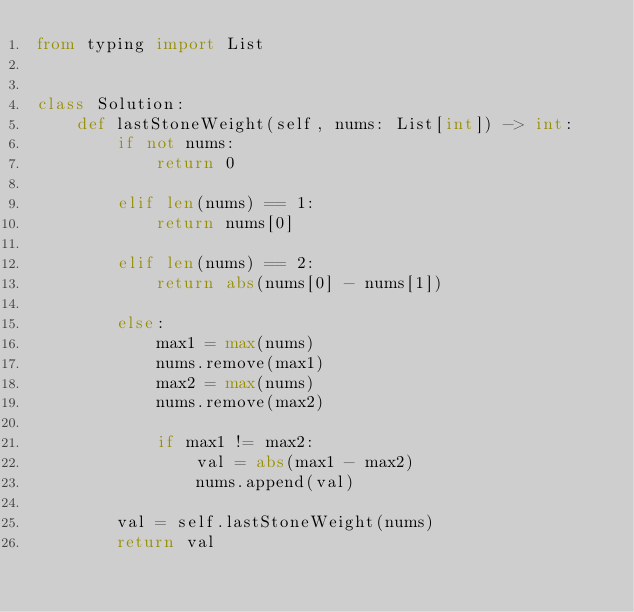Convert code to text. <code><loc_0><loc_0><loc_500><loc_500><_Python_>from typing import List


class Solution:
    def lastStoneWeight(self, nums: List[int]) -> int:
        if not nums:
            return 0

        elif len(nums) == 1:
            return nums[0]

        elif len(nums) == 2:
            return abs(nums[0] - nums[1])

        else:
            max1 = max(nums)
            nums.remove(max1)
            max2 = max(nums)
            nums.remove(max2)

            if max1 != max2:
                val = abs(max1 - max2)
                nums.append(val)

        val = self.lastStoneWeight(nums)
        return val
</code> 